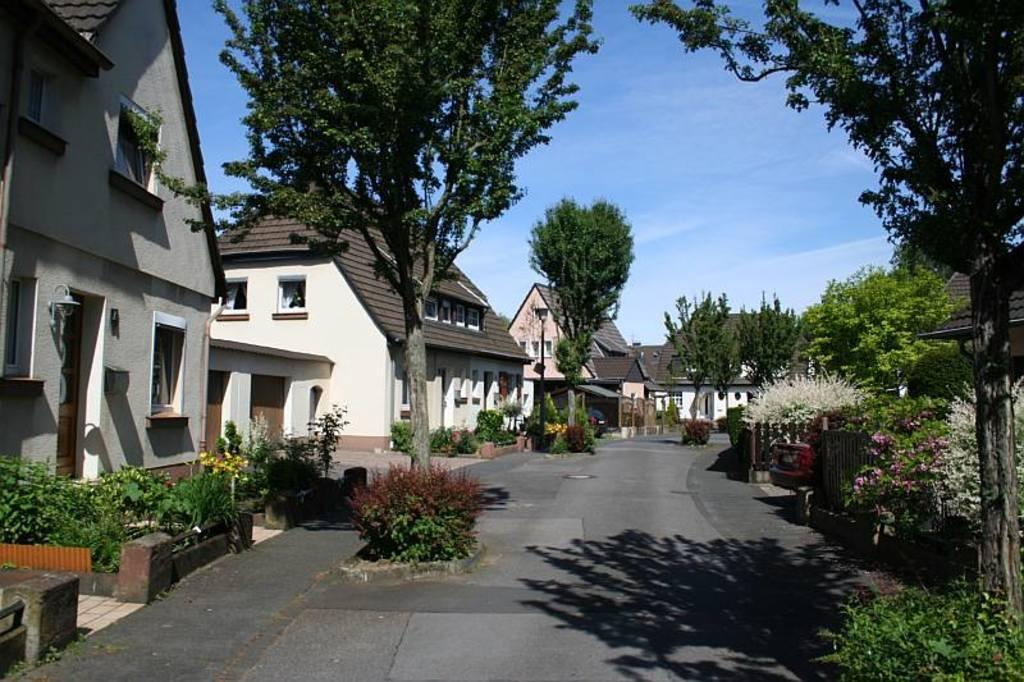What type of structures are located in the center of the image? There are houses in the center of the image. What type of vegetation can be seen in the image? There are trees in the image. What type of plants are present in the image? There are flower plants in the image. What type of cub can be seen playing with the cream in the image? There is no cub or cream present in the image. 